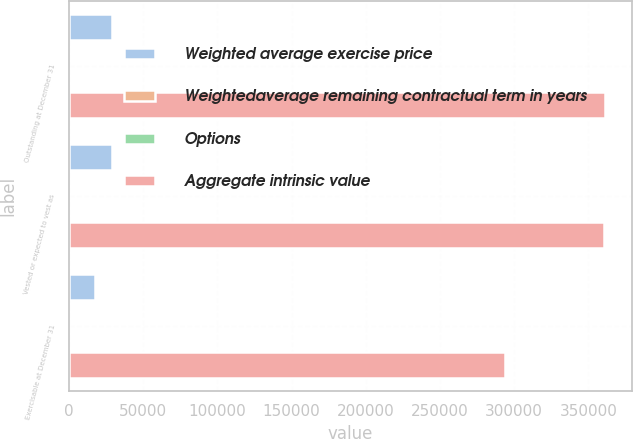Convert chart. <chart><loc_0><loc_0><loc_500><loc_500><stacked_bar_chart><ecel><fcel>Outstanding at December 31<fcel>Vested or expected to vest as<fcel>Exercisable at December 31<nl><fcel>Weighted average exercise price<fcel>29129<fcel>28642<fcel>17732<nl><fcel>Weightedaverage remaining contractual term in years<fcel>57<fcel>56.82<fcel>52.64<nl><fcel>Options<fcel>6.2<fcel>6.1<fcel>4.7<nl><fcel>Aggregate intrinsic value<fcel>361468<fcel>360329<fcel>293590<nl></chart> 